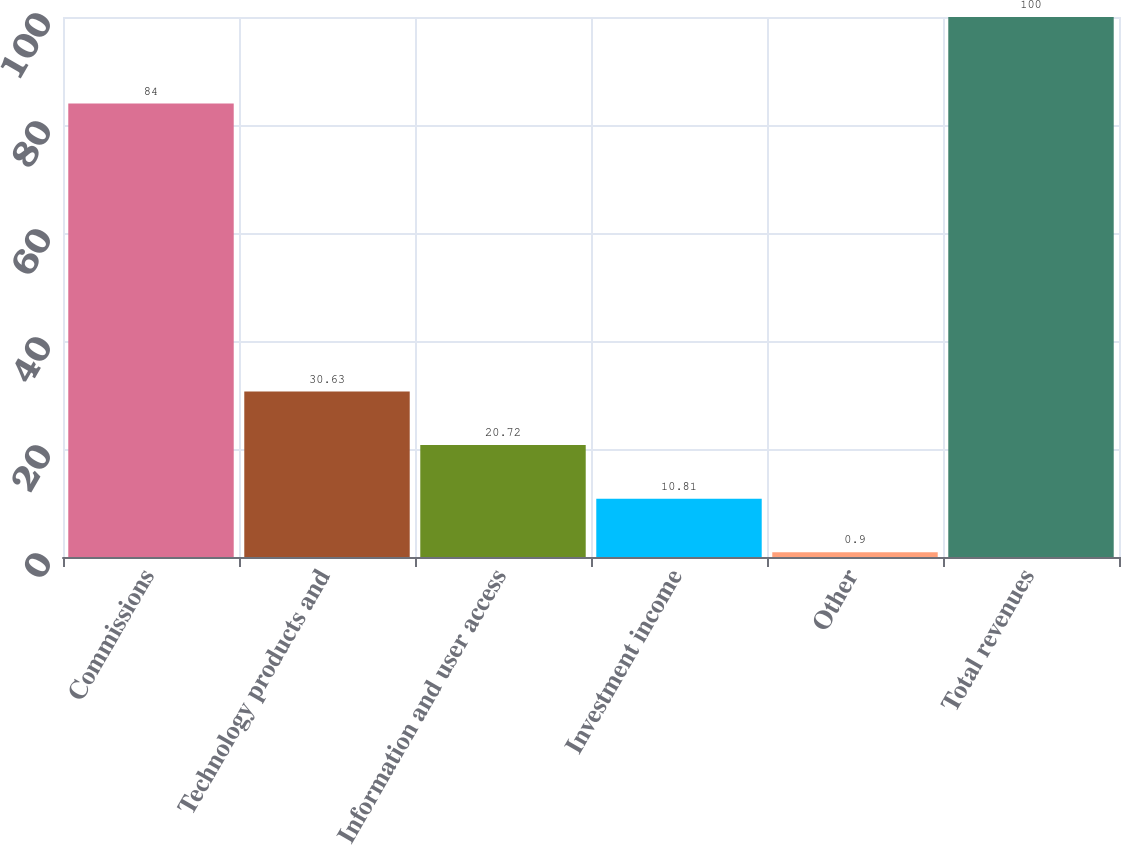<chart> <loc_0><loc_0><loc_500><loc_500><bar_chart><fcel>Commissions<fcel>Technology products and<fcel>Information and user access<fcel>Investment income<fcel>Other<fcel>Total revenues<nl><fcel>84<fcel>30.63<fcel>20.72<fcel>10.81<fcel>0.9<fcel>100<nl></chart> 